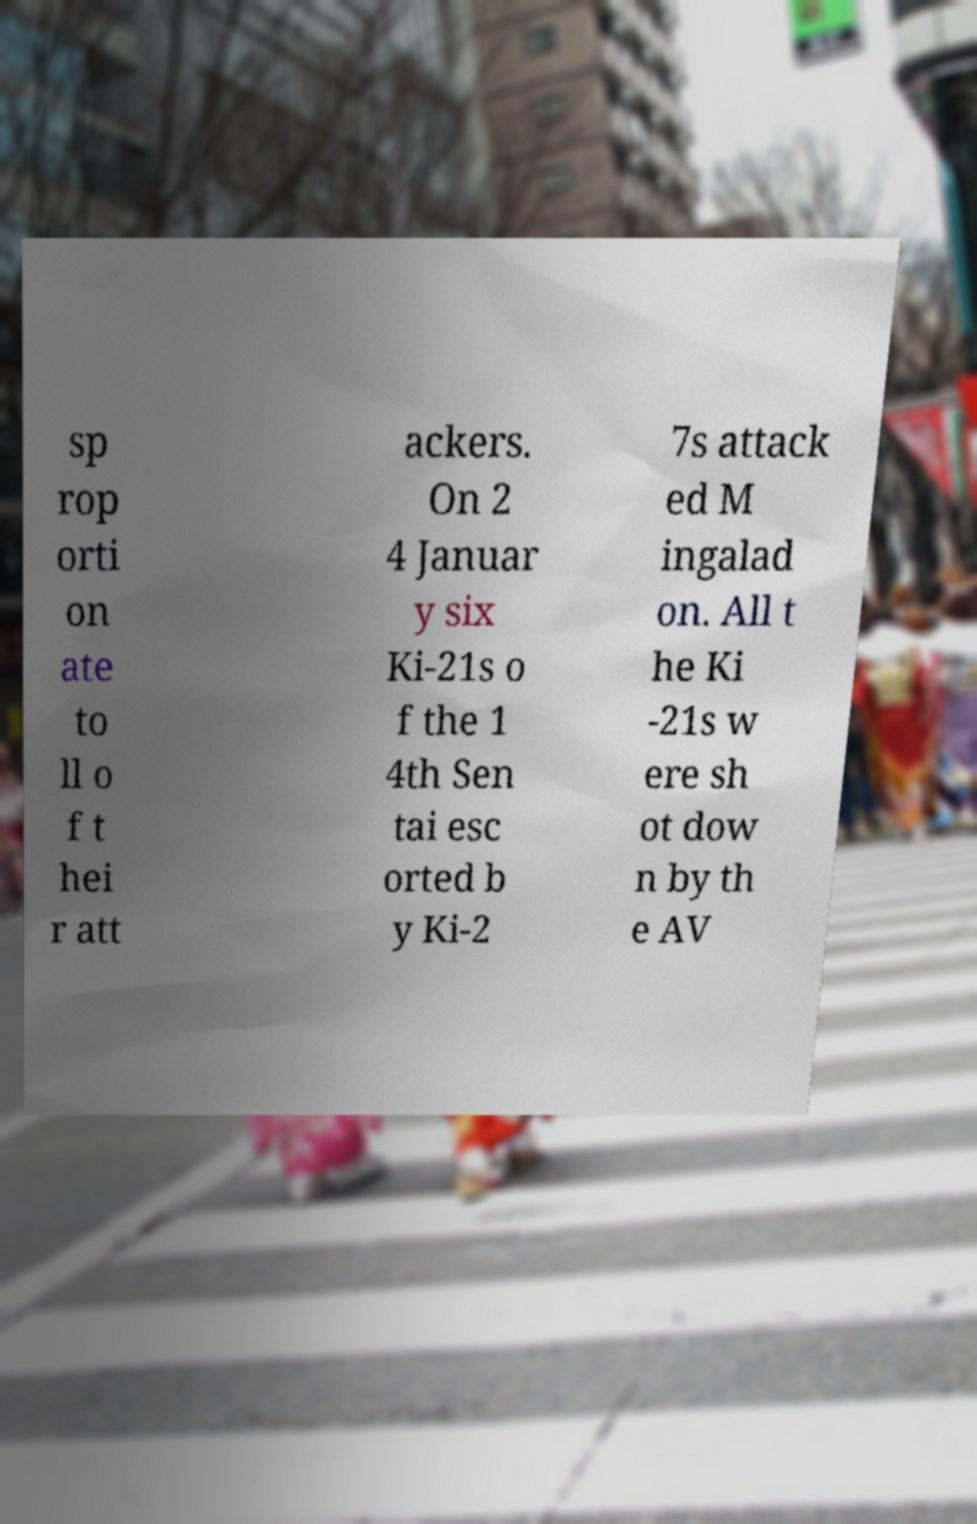I need the written content from this picture converted into text. Can you do that? sp rop orti on ate to ll o f t hei r att ackers. On 2 4 Januar y six Ki-21s o f the 1 4th Sen tai esc orted b y Ki-2 7s attack ed M ingalad on. All t he Ki -21s w ere sh ot dow n by th e AV 